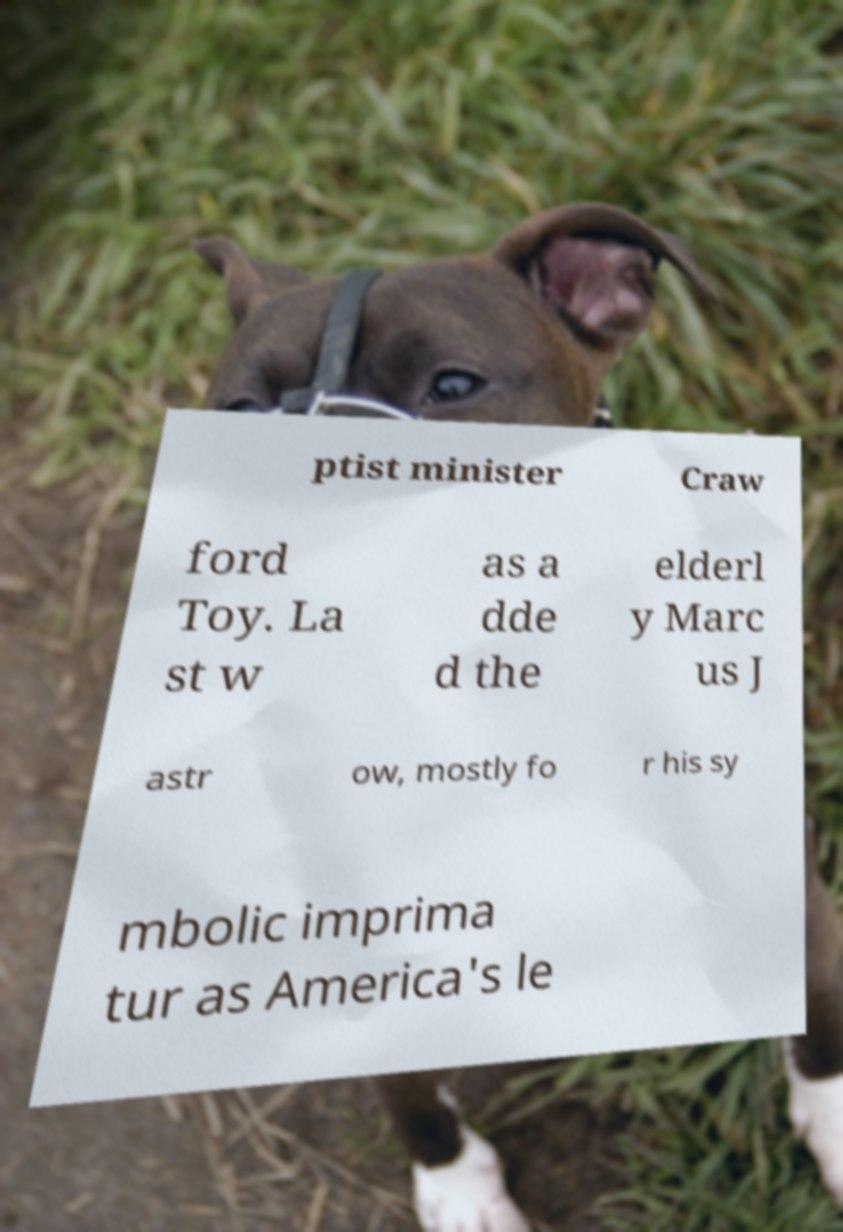There's text embedded in this image that I need extracted. Can you transcribe it verbatim? ptist minister Craw ford Toy. La st w as a dde d the elderl y Marc us J astr ow, mostly fo r his sy mbolic imprima tur as America's le 